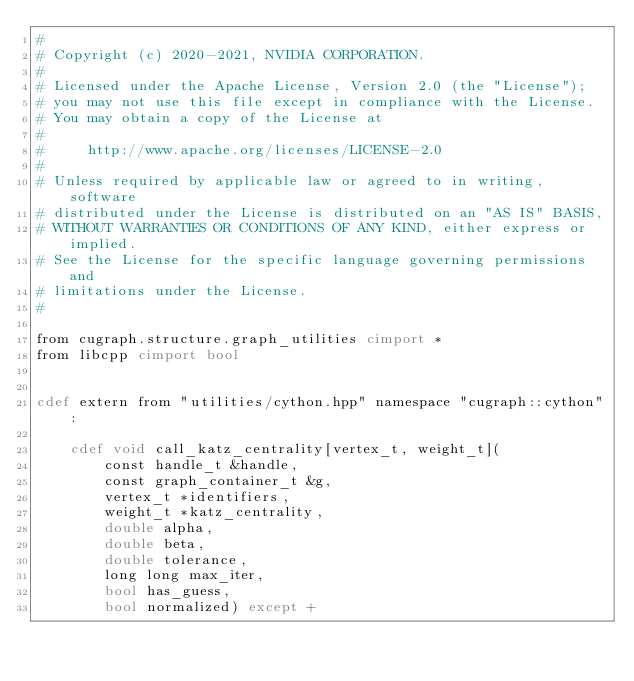Convert code to text. <code><loc_0><loc_0><loc_500><loc_500><_Cython_>#
# Copyright (c) 2020-2021, NVIDIA CORPORATION.
#
# Licensed under the Apache License, Version 2.0 (the "License");
# you may not use this file except in compliance with the License.
# You may obtain a copy of the License at
#
#     http://www.apache.org/licenses/LICENSE-2.0
#
# Unless required by applicable law or agreed to in writing, software
# distributed under the License is distributed on an "AS IS" BASIS,
# WITHOUT WARRANTIES OR CONDITIONS OF ANY KIND, either express or implied.
# See the License for the specific language governing permissions and
# limitations under the License.
#

from cugraph.structure.graph_utilities cimport *
from libcpp cimport bool


cdef extern from "utilities/cython.hpp" namespace "cugraph::cython":

    cdef void call_katz_centrality[vertex_t, weight_t](
        const handle_t &handle,
        const graph_container_t &g,
        vertex_t *identifiers,
        weight_t *katz_centrality,
        double alpha,
        double beta,
        double tolerance,
        long long max_iter,
        bool has_guess,
        bool normalized) except +
</code> 